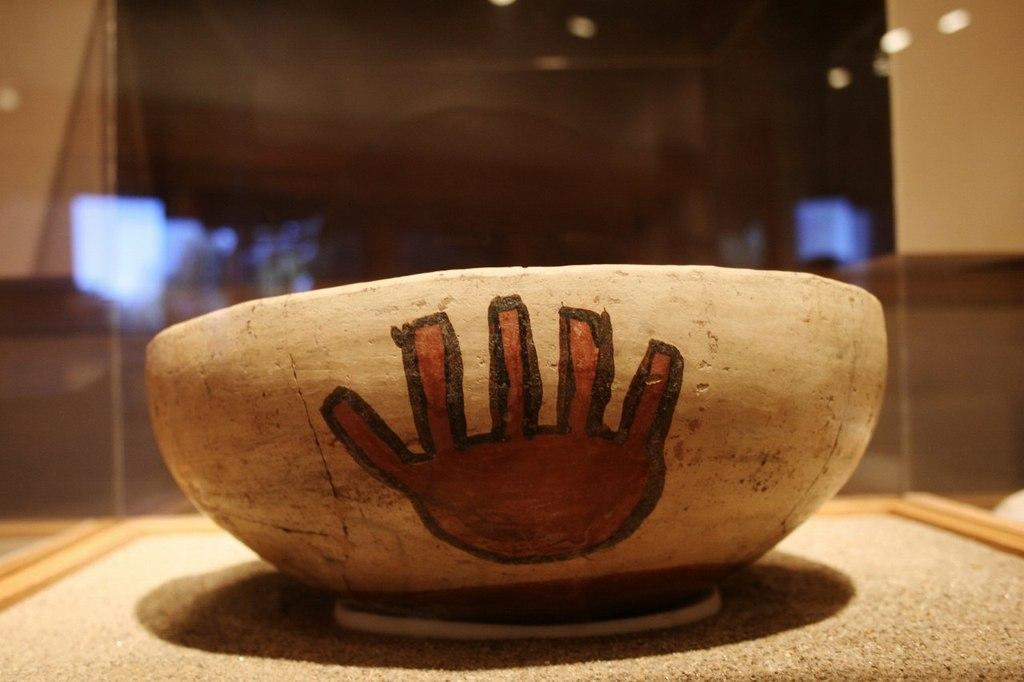Please provide a concise description of this image. In this image I can see the brown color object in front. In the background I can see the glass. 